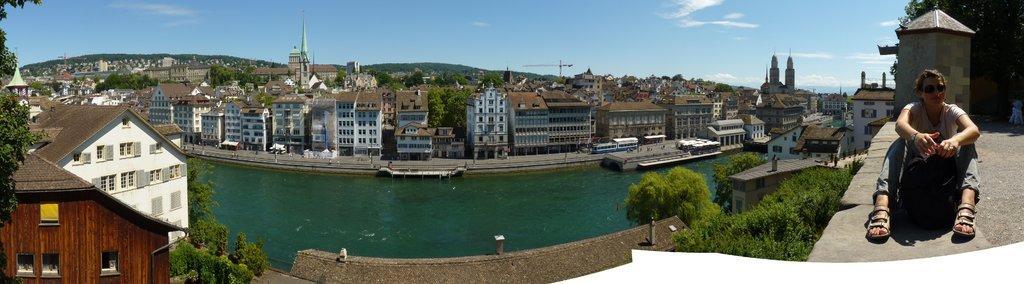In one or two sentences, can you explain what this image depicts? To the right corner of the image there is a person sitting on the floor. Behind the person there is a room with roof and tree. To the left side of the image there are houses with roofs, walls and windows. And also there are trees. In the middle of the image there is water. Behind the water there is a footpath with few people. And also there are many houses with roofs, windows, walls and poles. And also there are many trees. Behind the houses there are hills. And to the top of the image there is a sky. 